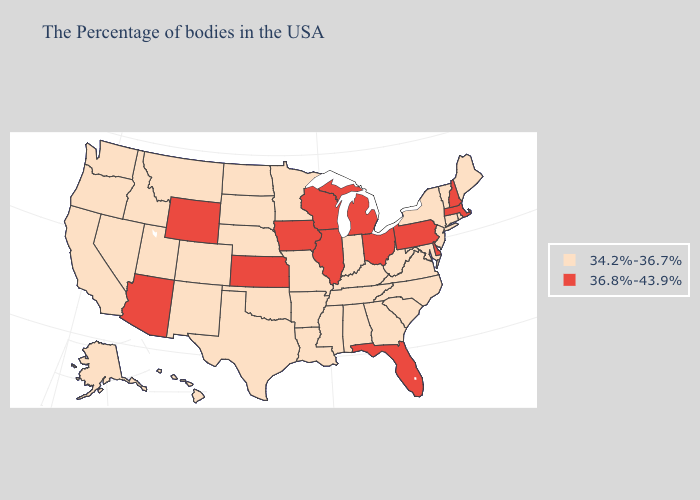Does Kentucky have the same value as New Hampshire?
Give a very brief answer. No. What is the highest value in the USA?
Quick response, please. 36.8%-43.9%. What is the highest value in the Northeast ?
Short answer required. 36.8%-43.9%. Does Utah have a lower value than West Virginia?
Give a very brief answer. No. What is the highest value in states that border Massachusetts?
Quick response, please. 36.8%-43.9%. Does the map have missing data?
Be succinct. No. What is the value of Nebraska?
Be succinct. 34.2%-36.7%. Which states hav the highest value in the South?
Write a very short answer. Delaware, Florida. What is the highest value in states that border North Carolina?
Quick response, please. 34.2%-36.7%. What is the value of Illinois?
Be succinct. 36.8%-43.9%. Name the states that have a value in the range 34.2%-36.7%?
Give a very brief answer. Maine, Rhode Island, Vermont, Connecticut, New York, New Jersey, Maryland, Virginia, North Carolina, South Carolina, West Virginia, Georgia, Kentucky, Indiana, Alabama, Tennessee, Mississippi, Louisiana, Missouri, Arkansas, Minnesota, Nebraska, Oklahoma, Texas, South Dakota, North Dakota, Colorado, New Mexico, Utah, Montana, Idaho, Nevada, California, Washington, Oregon, Alaska, Hawaii. Name the states that have a value in the range 34.2%-36.7%?
Short answer required. Maine, Rhode Island, Vermont, Connecticut, New York, New Jersey, Maryland, Virginia, North Carolina, South Carolina, West Virginia, Georgia, Kentucky, Indiana, Alabama, Tennessee, Mississippi, Louisiana, Missouri, Arkansas, Minnesota, Nebraska, Oklahoma, Texas, South Dakota, North Dakota, Colorado, New Mexico, Utah, Montana, Idaho, Nevada, California, Washington, Oregon, Alaska, Hawaii. Name the states that have a value in the range 36.8%-43.9%?
Give a very brief answer. Massachusetts, New Hampshire, Delaware, Pennsylvania, Ohio, Florida, Michigan, Wisconsin, Illinois, Iowa, Kansas, Wyoming, Arizona. How many symbols are there in the legend?
Write a very short answer. 2. What is the lowest value in the West?
Answer briefly. 34.2%-36.7%. 